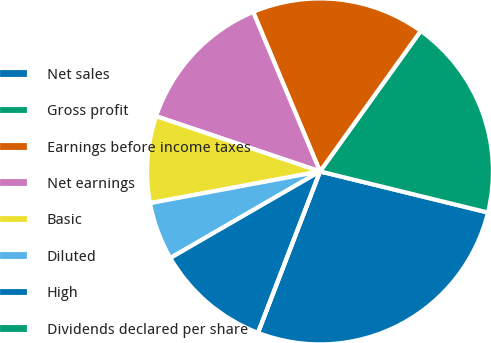Convert chart. <chart><loc_0><loc_0><loc_500><loc_500><pie_chart><fcel>Net sales<fcel>Gross profit<fcel>Earnings before income taxes<fcel>Net earnings<fcel>Basic<fcel>Diluted<fcel>High<fcel>Dividends declared per share<nl><fcel>27.02%<fcel>18.92%<fcel>16.22%<fcel>13.51%<fcel>8.11%<fcel>5.41%<fcel>10.81%<fcel>0.0%<nl></chart> 